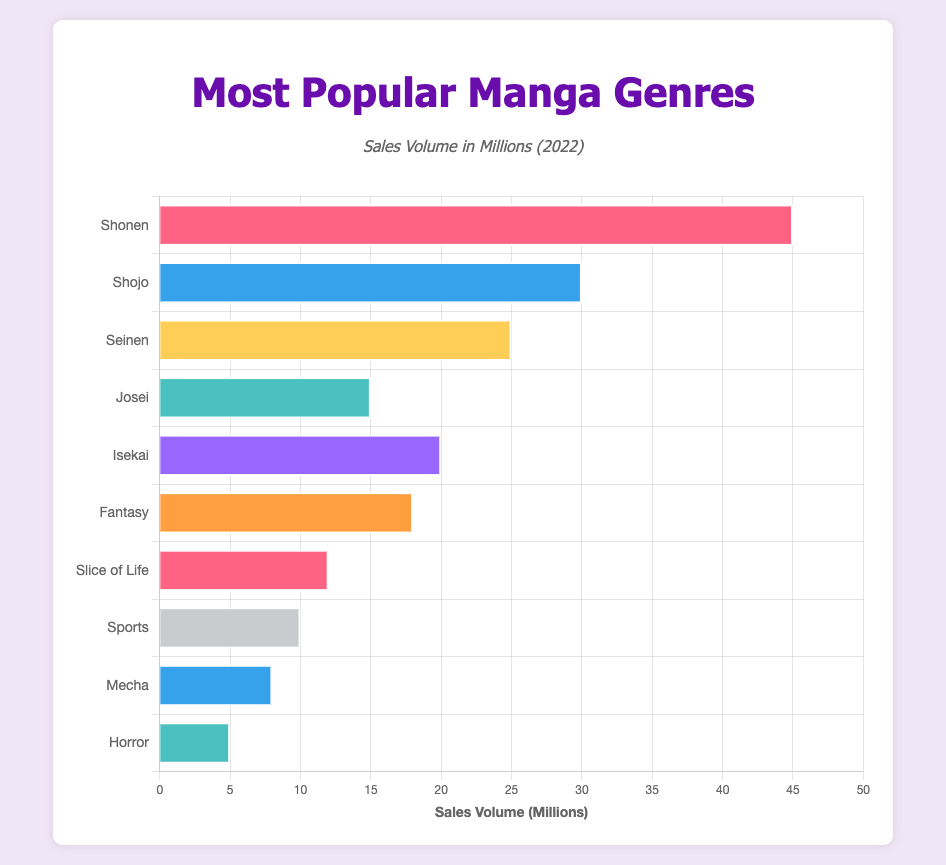Which genre had the highest sales volume in 2022? The bar chart shows that the Shonen genre has the longest bar, which indicates the highest sales volume, at 45 million.
Answer: Shonen What is the total sales volume of Shojo, Seinen, and Josei combined? Adding the sales volumes of Shojo (30 million), Seinen (25 million), and Josei (15 million) gives 30 + 25 + 15 = 70 million.
Answer: 70 million How much higher are the sales volumes of Shonen compared to Horror? The sales volume of Shonen is 45 million, while that of Horror is 5 million. The difference is 45 - 5 = 40 million.
Answer: 40 million Which genres have a sales volume greater than or equal to 20 million? Observing the bar lengths, the genres with sales volumes ≥ 20 million are Shonen (45 million), Shojo (30 million), Seinen (25 million), and Isekai (20 million).
Answer: Shonen, Shojo, Seinen, Isekai Calculate the average sales volume of all genres represented in the bar chart. Summing up the sales volumes: 45 + 30 + 25 + 15 + 20 + 18 + 12 + 10 + 8 + 5 = 188 million. There are 10 genres, so the average is 188/10 = 18.8 million.
Answer: 18.8 million Is the sales volume of Fantasy closer to the sales volume of Isekai or Josei? The sales volume of Fantasy is 18 million. It is 2 million less than Isekai (20 million) and 3 million more than Josei (15 million). Since 2 million is less than 3 million, Fantasy is closer to Isekai.
Answer: Isekai Which genre has a bar colored blue? Observing the colors in the chart, the bar colored blue represents the Shojo genre.
Answer: Shojo Between Slice of Life and Sports, which genre has a higher sales volume, and by how much? The sales volume for Slice of Life is 12 million, and that for Sports is 10 million. The difference is 12 - 10 = 2 million.
Answer: Slice of Life by 2 million What is the median sales volume of the genres? Listing the sales volumes in ascending order: 5, 8, 10, 12, 15, 18, 20, 25, 30, 45. With 10 values, the median is the average of the 5th and 6th values: (15 + 18)/2 = 16.5 million.
Answer: 16.5 million 